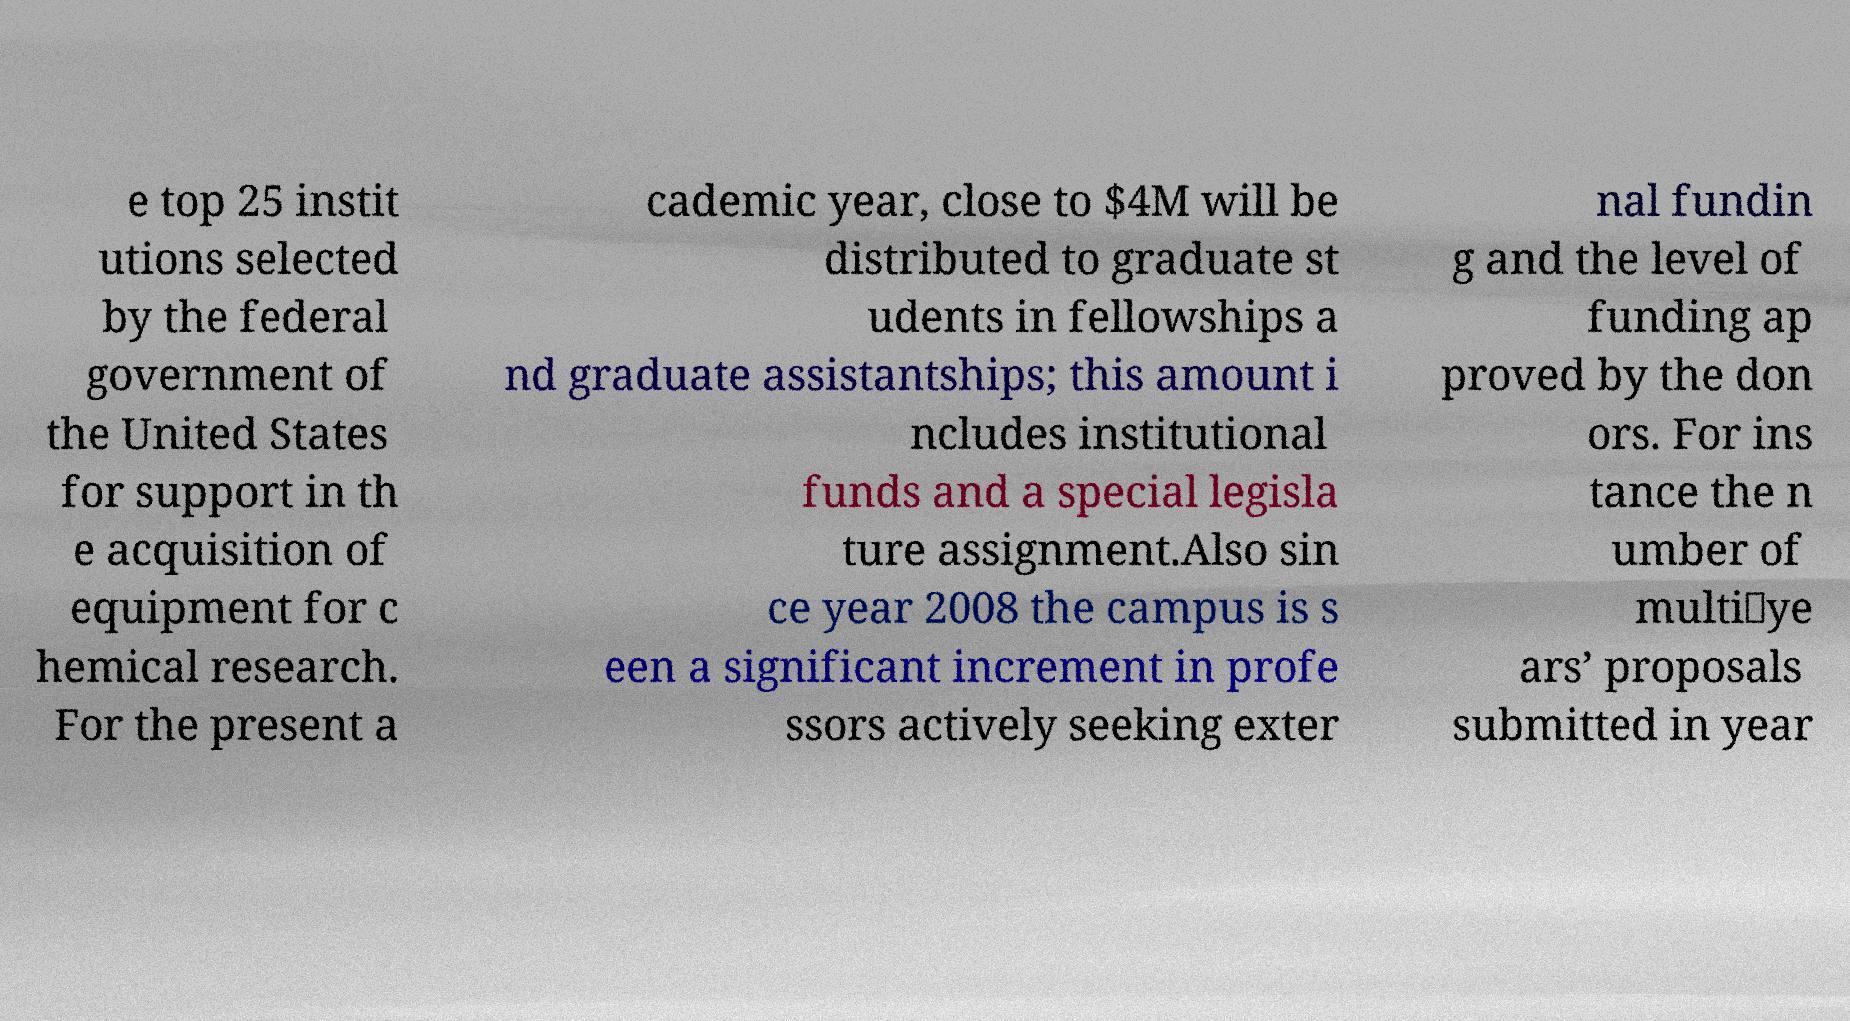Please read and relay the text visible in this image. What does it say? e top 25 instit utions selected by the federal government of the United States for support in th e acquisition of equipment for c hemical research. For the present a cademic year, close to $4M will be distributed to graduate st udents in fellowships a nd graduate assistantships; this amount i ncludes institutional funds and a special legisla ture assignment.Also sin ce year 2008 the campus is s een a significant increment in profe ssors actively seeking exter nal fundin g and the level of funding ap proved by the don ors. For ins tance the n umber of multi‐ye ars’ proposals submitted in year 